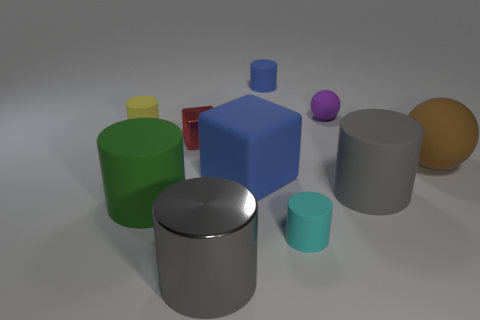Subtract all cyan cylinders. How many cylinders are left? 5 Subtract all yellow cylinders. How many cylinders are left? 5 Subtract all brown cylinders. Subtract all red blocks. How many cylinders are left? 6 Subtract all cubes. How many objects are left? 8 Subtract all cyan objects. Subtract all purple spheres. How many objects are left? 8 Add 2 big green rubber cylinders. How many big green rubber cylinders are left? 3 Add 7 large blue matte things. How many large blue matte things exist? 8 Subtract 1 cyan cylinders. How many objects are left? 9 